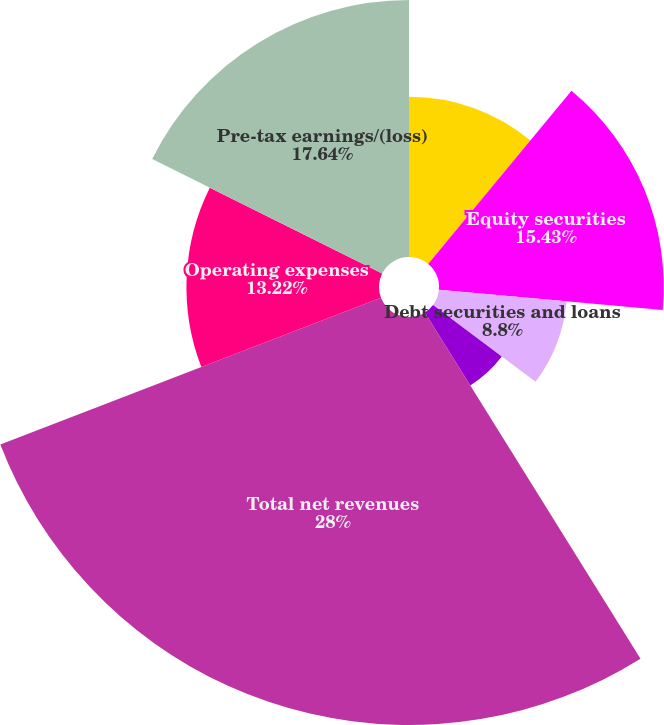<chart> <loc_0><loc_0><loc_500><loc_500><pie_chart><fcel>in millions<fcel>Equity securities<fcel>Debt securities and loans<fcel>Other<fcel>Total net revenues<fcel>Operating expenses<fcel>Pre-tax earnings/(loss)<nl><fcel>11.01%<fcel>15.43%<fcel>8.8%<fcel>5.9%<fcel>28.01%<fcel>13.22%<fcel>17.64%<nl></chart> 